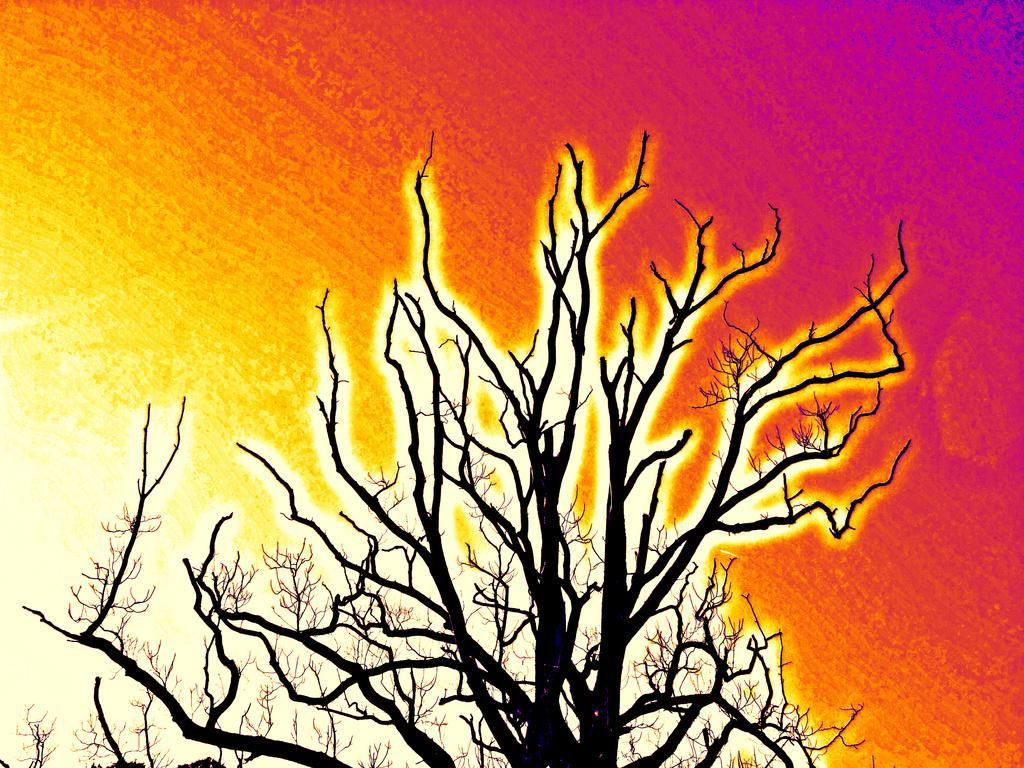Describe this image in one or two sentences. In this image we can see a painting which includes a dry tree and colorful background. 